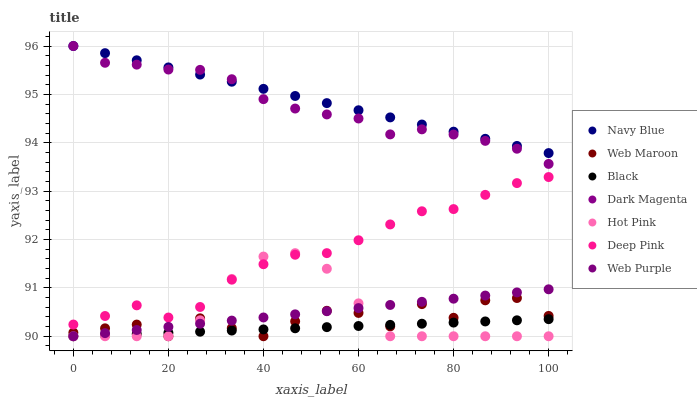Does Black have the minimum area under the curve?
Answer yes or no. Yes. Does Navy Blue have the maximum area under the curve?
Answer yes or no. Yes. Does Dark Magenta have the minimum area under the curve?
Answer yes or no. No. Does Dark Magenta have the maximum area under the curve?
Answer yes or no. No. Is Web Purple the smoothest?
Answer yes or no. Yes. Is Web Maroon the roughest?
Answer yes or no. Yes. Is Dark Magenta the smoothest?
Answer yes or no. No. Is Dark Magenta the roughest?
Answer yes or no. No. Does Hot Pink have the lowest value?
Answer yes or no. Yes. Does Dark Magenta have the lowest value?
Answer yes or no. No. Does Navy Blue have the highest value?
Answer yes or no. Yes. Does Hot Pink have the highest value?
Answer yes or no. No. Is Web Purple less than Dark Magenta?
Answer yes or no. Yes. Is Navy Blue greater than Hot Pink?
Answer yes or no. Yes. Does Web Purple intersect Web Maroon?
Answer yes or no. Yes. Is Web Purple less than Web Maroon?
Answer yes or no. No. Is Web Purple greater than Web Maroon?
Answer yes or no. No. Does Web Purple intersect Dark Magenta?
Answer yes or no. No. 